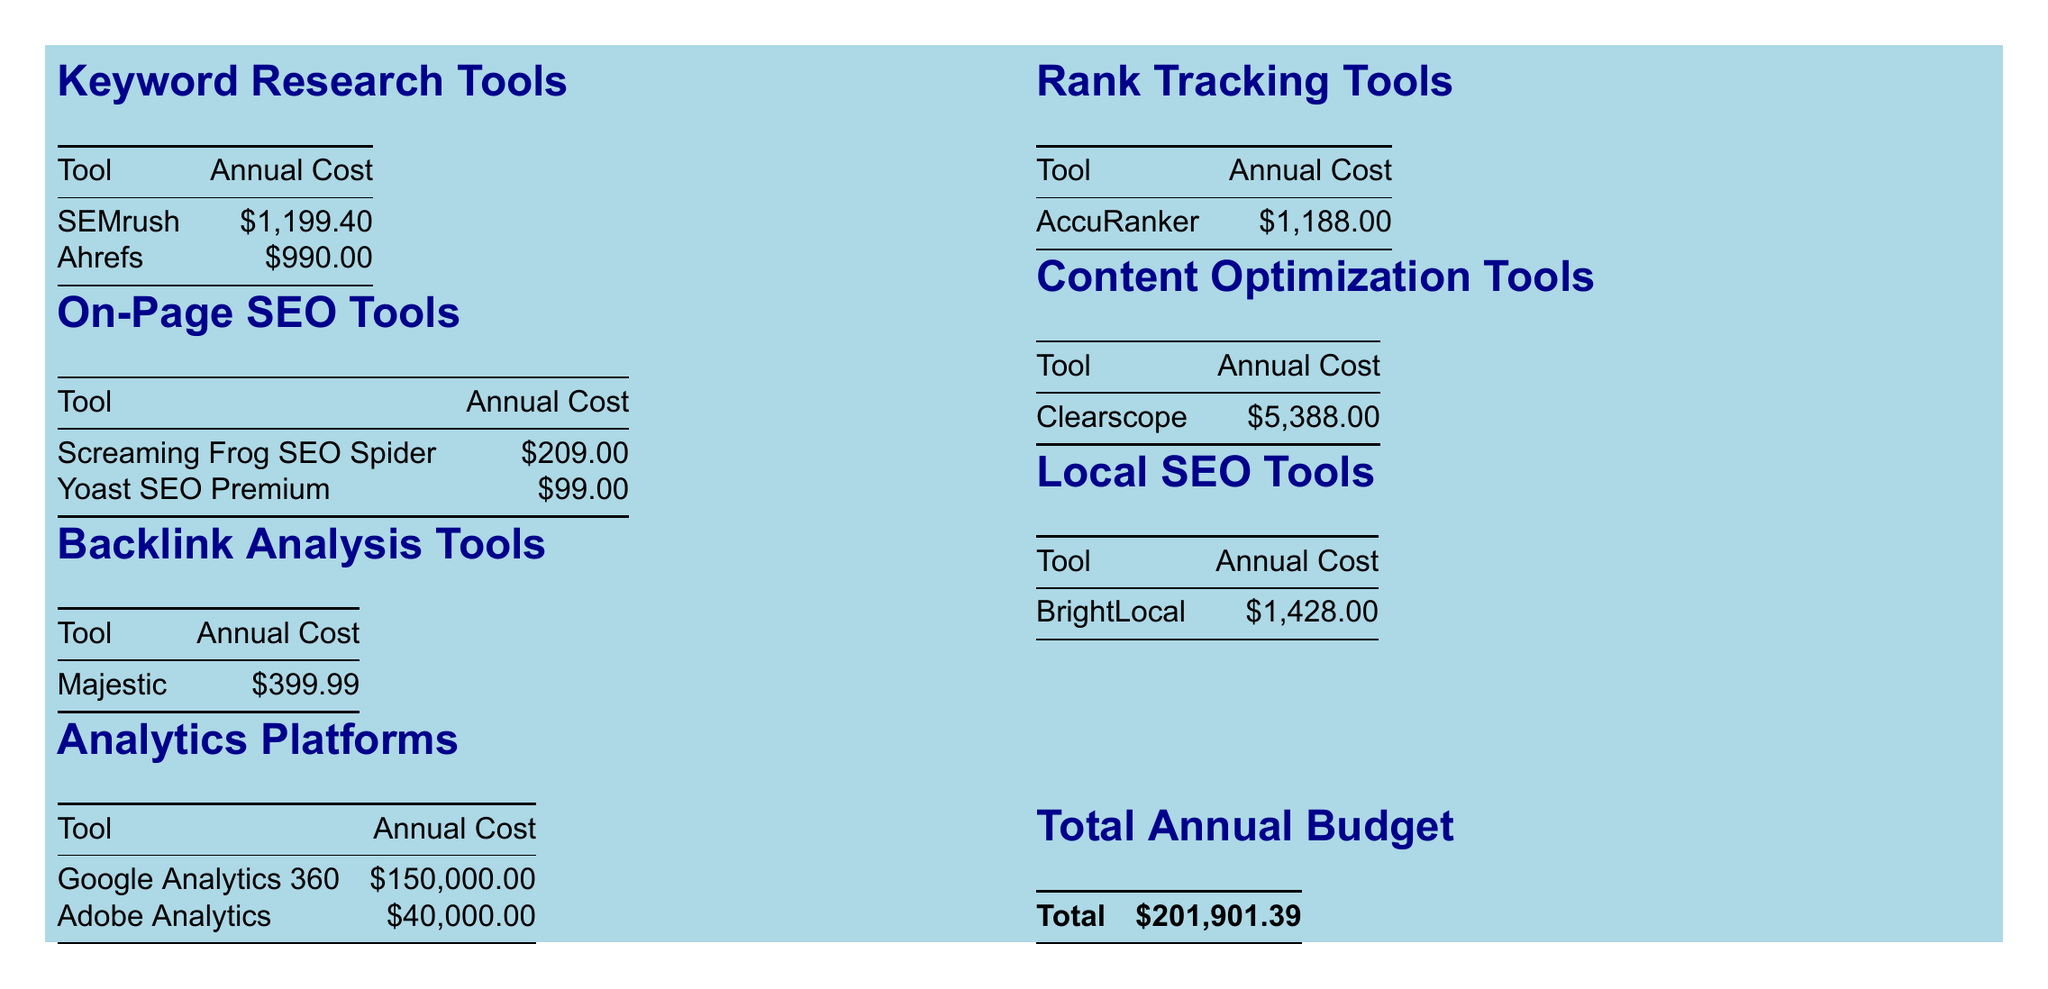What is the annual cost of SEMrush? The annual cost for SEMrush is specified in the Keyword Research Tools section of the document.
Answer: $1,199.40 How much does Google Analytics 360 cost annually? The annual cost for Google Analytics 360 is listed under the Analytics Platforms section of the document.
Answer: $150,000.00 What is the total annual budget for SEO tools? The total annual budget is calculated from all the individual costs listed in the document and is presented in the Total Annual Budget section.
Answer: $201,901.39 Which tool has the highest annual cost? To find the tool with the highest cost, one must compare all listed costs in the document. Google Analytics 360 is the most expensive.
Answer: Google Analytics 360 How many tools are listed in the On-Page SEO Tools section? The document specifies the number of tools under each category, and for On-Page SEO Tools, there are 2 listed.
Answer: 2 What is the annual cost of Yoast SEO Premium? The annual cost for Yoast SEO Premium is stated in the On-Page SEO Tools table within the document.
Answer: $99.00 What category does BrightLocal belong to? The category information is listed alongside the tools in the budget breakdown. BrightLocal is classified under Local SEO Tools.
Answer: Local SEO Tools What is the combined cost of all keyword research tools? The combined cost requires adding the annual costs of all the tools in the Keyword Research Tools section of the document.
Answer: $2,189.40 